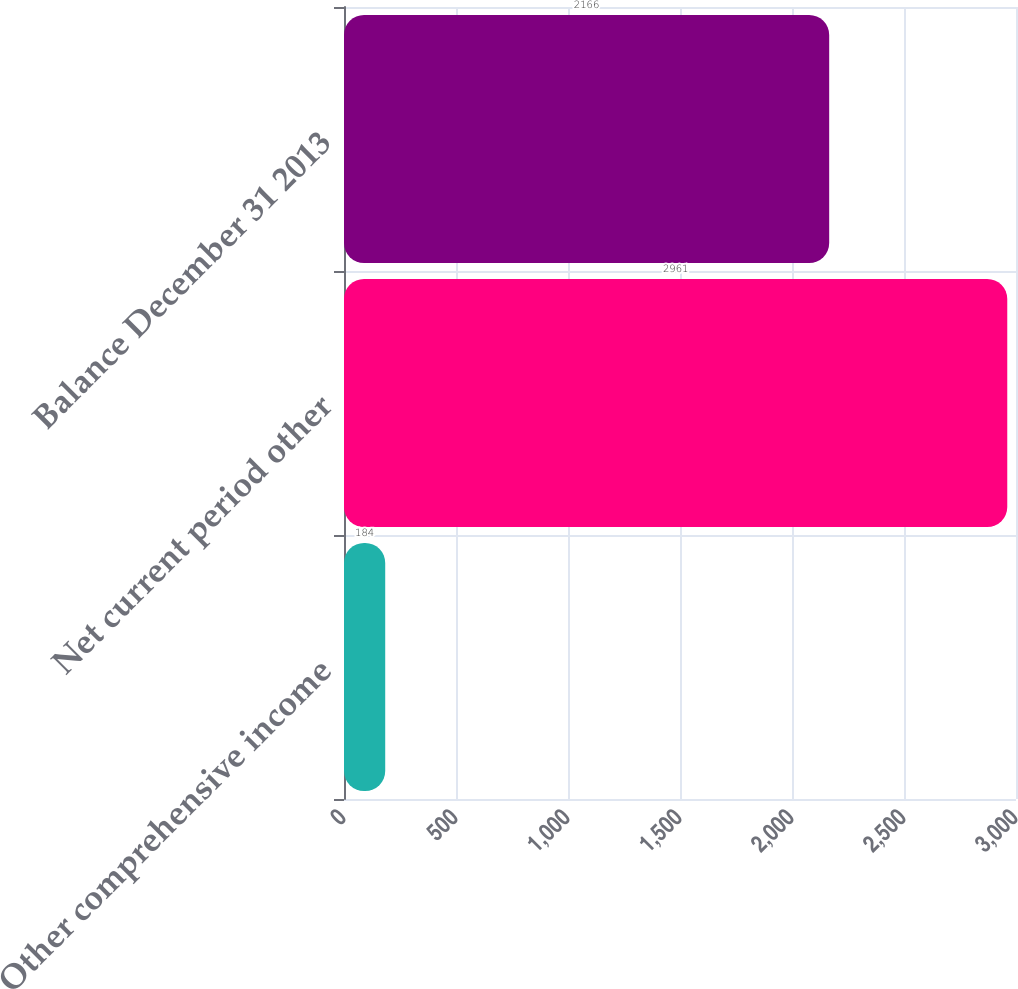Convert chart to OTSL. <chart><loc_0><loc_0><loc_500><loc_500><bar_chart><fcel>Other comprehensive income<fcel>Net current period other<fcel>Balance December 31 2013<nl><fcel>184<fcel>2961<fcel>2166<nl></chart> 